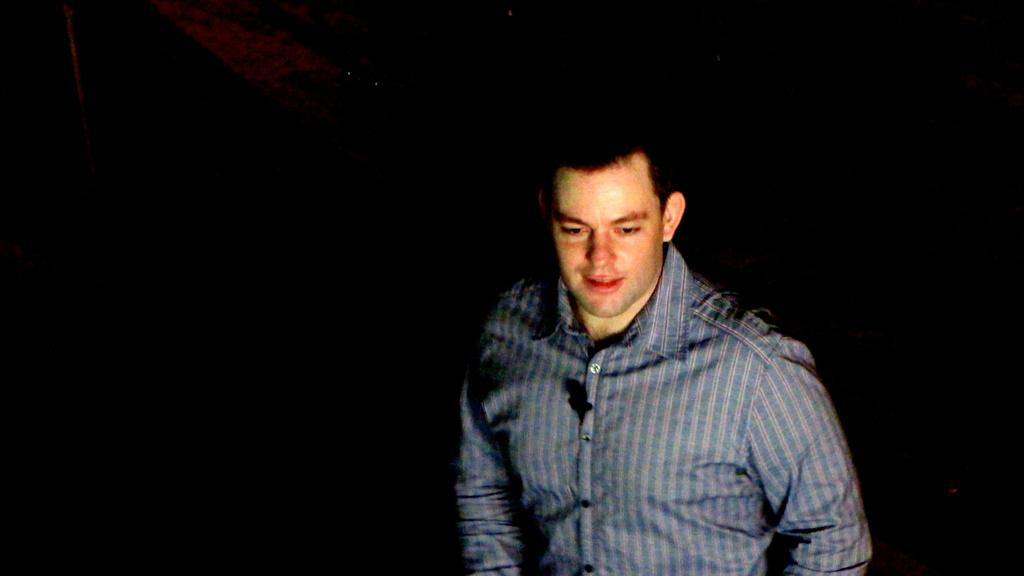What is the main subject of the image? There is a man in the image. What is the man doing in the image? The man is smiling in the image. What can be observed about the background of the image? The background of the image is dark. What type of motion is the stem exhibiting in the image? There is no stem present in the image; it features a man who is smiling. 